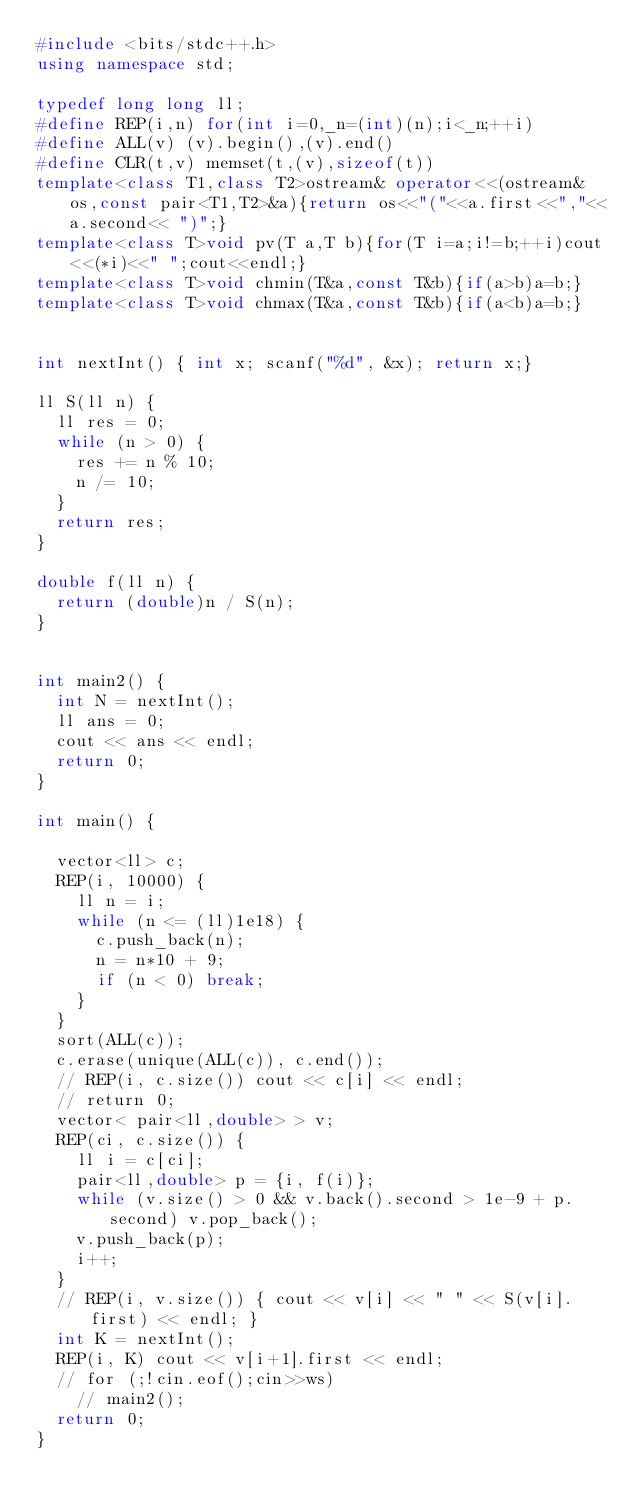Convert code to text. <code><loc_0><loc_0><loc_500><loc_500><_C++_>#include <bits/stdc++.h>
using namespace std;

typedef long long ll;
#define REP(i,n) for(int i=0,_n=(int)(n);i<_n;++i)
#define ALL(v) (v).begin(),(v).end()
#define CLR(t,v) memset(t,(v),sizeof(t))
template<class T1,class T2>ostream& operator<<(ostream& os,const pair<T1,T2>&a){return os<<"("<<a.first<<","<<a.second<< ")";}
template<class T>void pv(T a,T b){for(T i=a;i!=b;++i)cout<<(*i)<<" ";cout<<endl;}
template<class T>void chmin(T&a,const T&b){if(a>b)a=b;}
template<class T>void chmax(T&a,const T&b){if(a<b)a=b;}


int nextInt() { int x; scanf("%d", &x); return x;}

ll S(ll n) {
  ll res = 0;
  while (n > 0) {
    res += n % 10;
    n /= 10;
  }
  return res;
}

double f(ll n) {
  return (double)n / S(n);
}


int main2() {
  int N = nextInt();
  ll ans = 0;
  cout << ans << endl;
  return 0;
}

int main() {

  vector<ll> c;
  REP(i, 10000) {
    ll n = i;
    while (n <= (ll)1e18) {
      c.push_back(n);
      n = n*10 + 9;
      if (n < 0) break;
    }
  }
  sort(ALL(c));
  c.erase(unique(ALL(c)), c.end());
  // REP(i, c.size()) cout << c[i] << endl;
  // return 0;
  vector< pair<ll,double> > v;
  REP(ci, c.size()) {
    ll i = c[ci];
    pair<ll,double> p = {i, f(i)};
    while (v.size() > 0 && v.back().second > 1e-9 + p.second) v.pop_back();
    v.push_back(p);
    i++;
  }
  // REP(i, v.size()) { cout << v[i] << " " << S(v[i].first) << endl; }
  int K = nextInt();
  REP(i, K) cout << v[i+1].first << endl;
  // for (;!cin.eof();cin>>ws)
    // main2();
  return 0;
}
</code> 